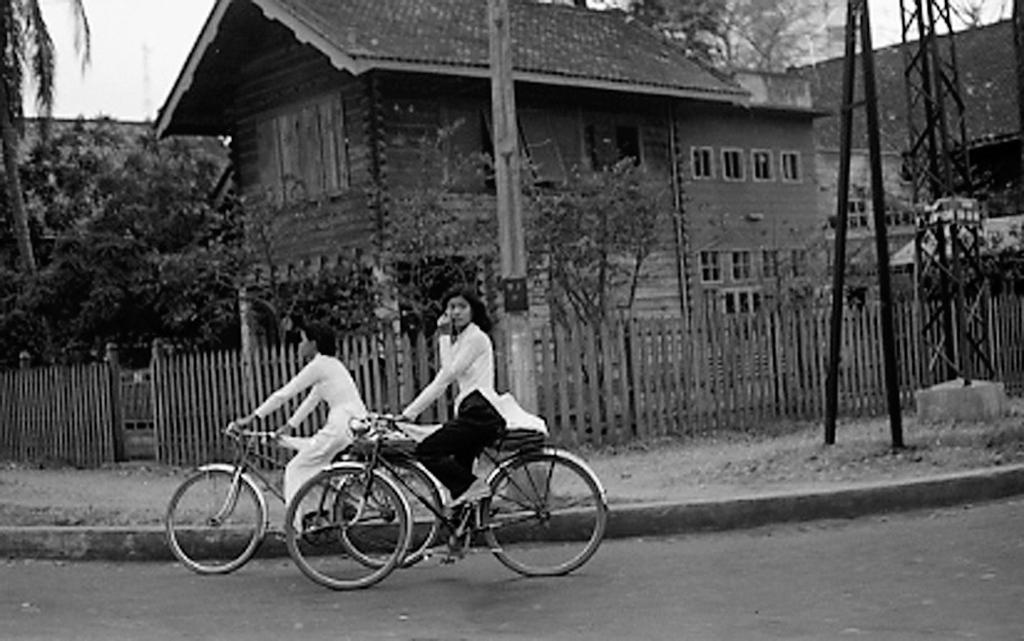How many women are in the image? There are two women in the image. What are the women doing in the image? The women are riding bicycles. What can be seen in the background of the image? There are houses, the sky, trees, plants, a pole, and a stand visible in the background of the image. What is the name of the book that the women are reading while riding their bicycles? There is no book present in the image, as the women are riding bicycles and not reading. 